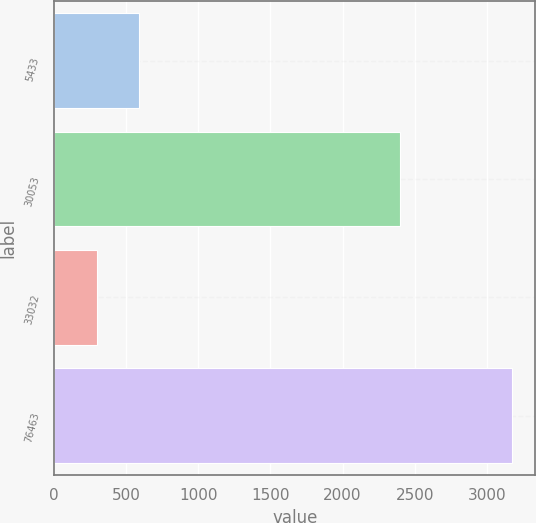Convert chart to OTSL. <chart><loc_0><loc_0><loc_500><loc_500><bar_chart><fcel>5433<fcel>30053<fcel>33032<fcel>76463<nl><fcel>587.95<fcel>2396.8<fcel>300.1<fcel>3178.6<nl></chart> 